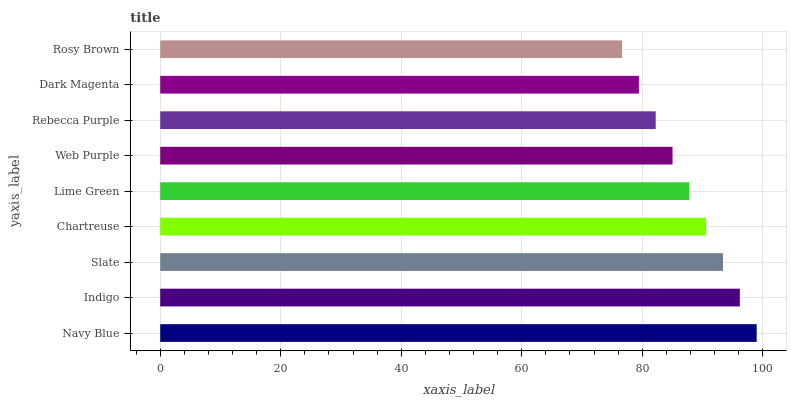Is Rosy Brown the minimum?
Answer yes or no. Yes. Is Navy Blue the maximum?
Answer yes or no. Yes. Is Indigo the minimum?
Answer yes or no. No. Is Indigo the maximum?
Answer yes or no. No. Is Navy Blue greater than Indigo?
Answer yes or no. Yes. Is Indigo less than Navy Blue?
Answer yes or no. Yes. Is Indigo greater than Navy Blue?
Answer yes or no. No. Is Navy Blue less than Indigo?
Answer yes or no. No. Is Lime Green the high median?
Answer yes or no. Yes. Is Lime Green the low median?
Answer yes or no. Yes. Is Rosy Brown the high median?
Answer yes or no. No. Is Dark Magenta the low median?
Answer yes or no. No. 